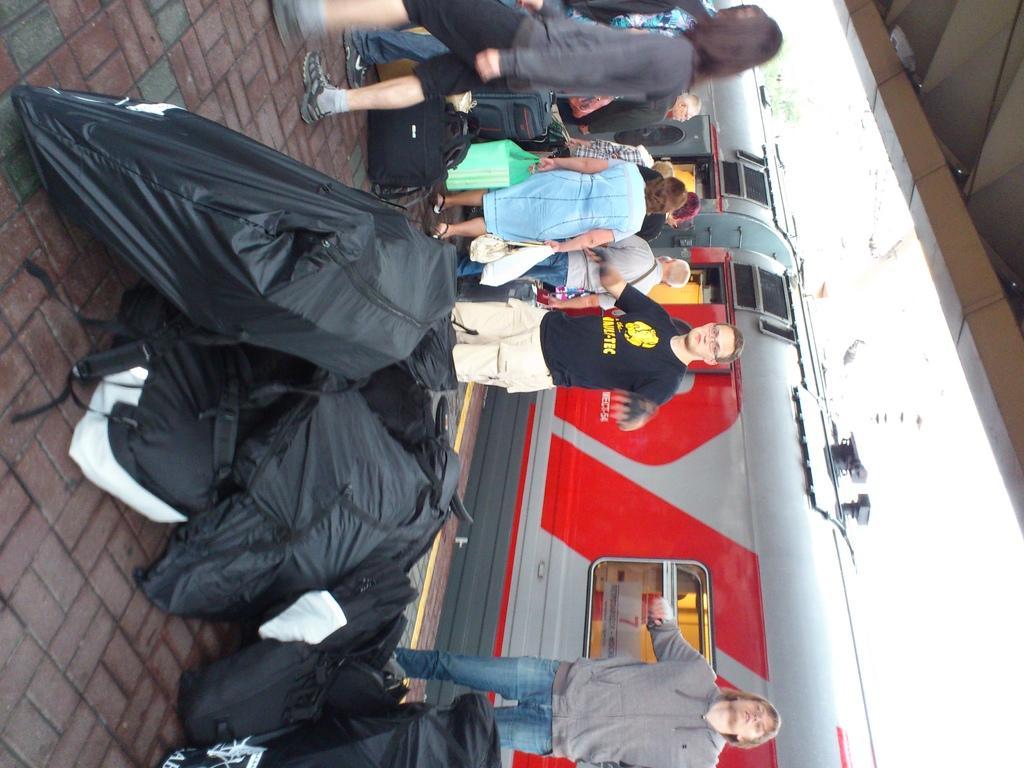How would you summarize this image in a sentence or two? In this image on the right side, we can see there is a train and there are people standing. 